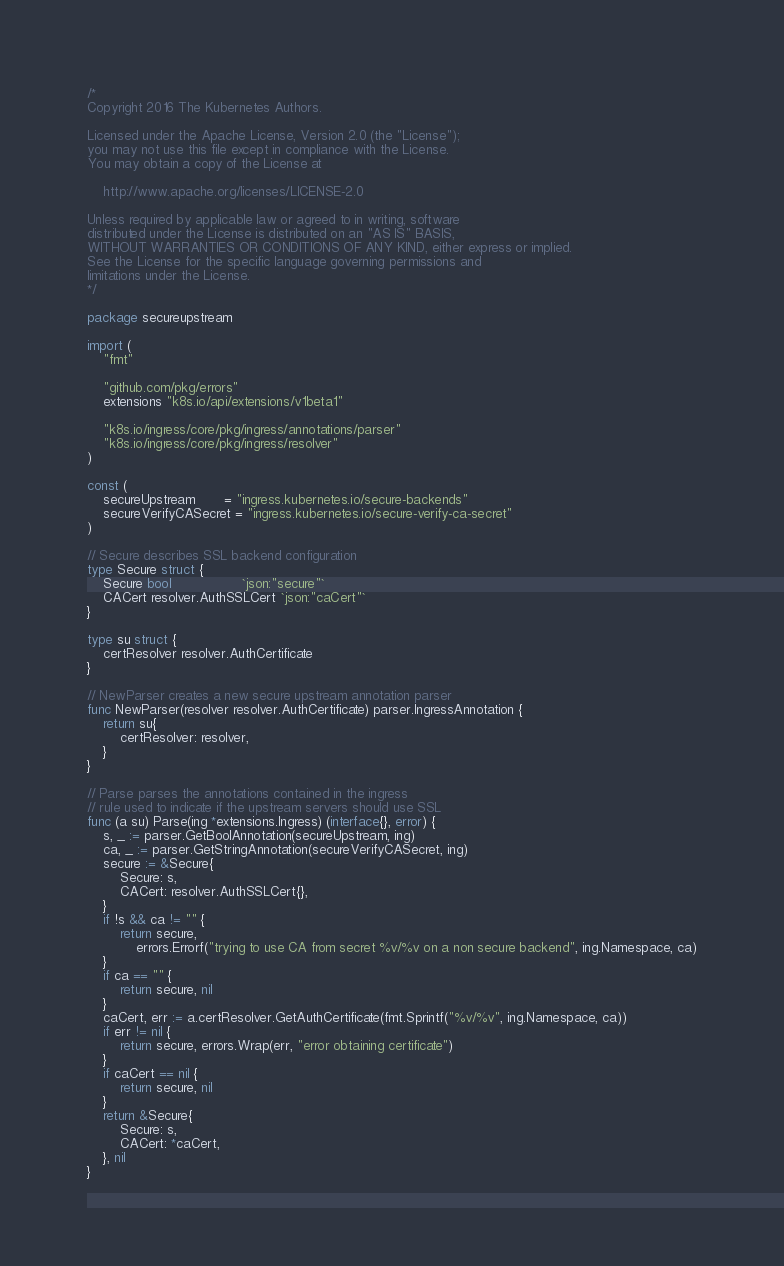Convert code to text. <code><loc_0><loc_0><loc_500><loc_500><_Go_>/*
Copyright 2016 The Kubernetes Authors.

Licensed under the Apache License, Version 2.0 (the "License");
you may not use this file except in compliance with the License.
You may obtain a copy of the License at

    http://www.apache.org/licenses/LICENSE-2.0

Unless required by applicable law or agreed to in writing, software
distributed under the License is distributed on an "AS IS" BASIS,
WITHOUT WARRANTIES OR CONDITIONS OF ANY KIND, either express or implied.
See the License for the specific language governing permissions and
limitations under the License.
*/

package secureupstream

import (
	"fmt"

	"github.com/pkg/errors"
	extensions "k8s.io/api/extensions/v1beta1"

	"k8s.io/ingress/core/pkg/ingress/annotations/parser"
	"k8s.io/ingress/core/pkg/ingress/resolver"
)

const (
	secureUpstream       = "ingress.kubernetes.io/secure-backends"
	secureVerifyCASecret = "ingress.kubernetes.io/secure-verify-ca-secret"
)

// Secure describes SSL backend configuration
type Secure struct {
	Secure bool                 `json:"secure"`
	CACert resolver.AuthSSLCert `json:"caCert"`
}

type su struct {
	certResolver resolver.AuthCertificate
}

// NewParser creates a new secure upstream annotation parser
func NewParser(resolver resolver.AuthCertificate) parser.IngressAnnotation {
	return su{
		certResolver: resolver,
	}
}

// Parse parses the annotations contained in the ingress
// rule used to indicate if the upstream servers should use SSL
func (a su) Parse(ing *extensions.Ingress) (interface{}, error) {
	s, _ := parser.GetBoolAnnotation(secureUpstream, ing)
	ca, _ := parser.GetStringAnnotation(secureVerifyCASecret, ing)
	secure := &Secure{
		Secure: s,
		CACert: resolver.AuthSSLCert{},
	}
	if !s && ca != "" {
		return secure,
			errors.Errorf("trying to use CA from secret %v/%v on a non secure backend", ing.Namespace, ca)
	}
	if ca == "" {
		return secure, nil
	}
	caCert, err := a.certResolver.GetAuthCertificate(fmt.Sprintf("%v/%v", ing.Namespace, ca))
	if err != nil {
		return secure, errors.Wrap(err, "error obtaining certificate")
	}
	if caCert == nil {
		return secure, nil
	}
	return &Secure{
		Secure: s,
		CACert: *caCert,
	}, nil
}
</code> 